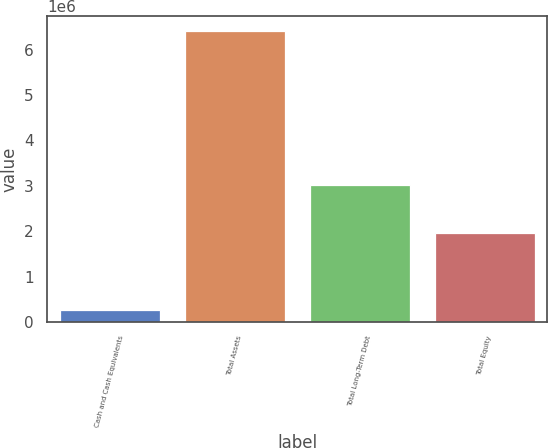Convert chart. <chart><loc_0><loc_0><loc_500><loc_500><bar_chart><fcel>Cash and Cash Equivalents<fcel>Total Assets<fcel>Total Long-Term Debt<fcel>Total Equity<nl><fcel>258693<fcel>6.41639e+06<fcel>3.00821e+06<fcel>1.95286e+06<nl></chart> 